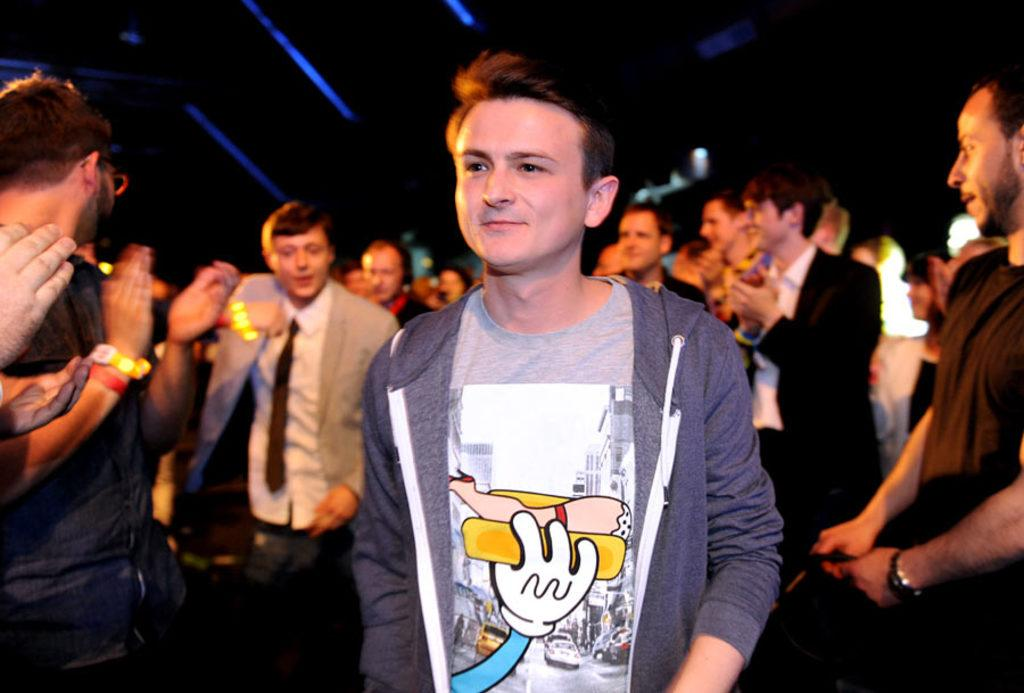What is the gender of the people in the image? There are men in the image. What are some of the men doing in the image? Some of the men are standing, and some are clapping their hands. What type of cushion is being used by the men in the image? There is no cushion present in the image; the men are standing and clapping their hands. 